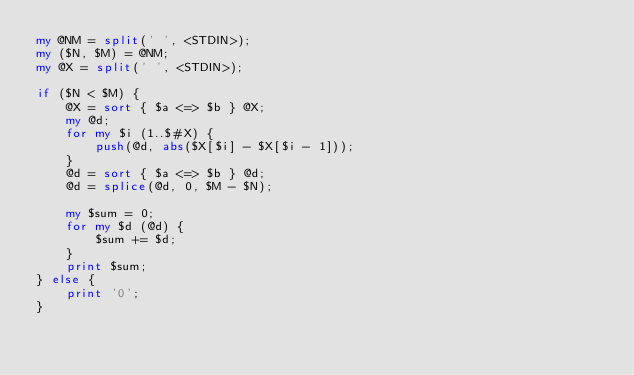Convert code to text. <code><loc_0><loc_0><loc_500><loc_500><_Perl_>my @NM = split(' ', <STDIN>);
my ($N, $M) = @NM;
my @X = split(' ', <STDIN>);

if ($N < $M) {
	@X = sort { $a <=> $b } @X;
	my @d;
	for my $i (1..$#X) {
		push(@d, abs($X[$i] - $X[$i - 1]));
	}
	@d = sort { $a <=> $b } @d;
	@d = splice(@d, 0, $M - $N);

	my $sum = 0;
	for my $d (@d) {
		$sum += $d;
	}
	print $sum;
} else {
	print '0';
}
</code> 